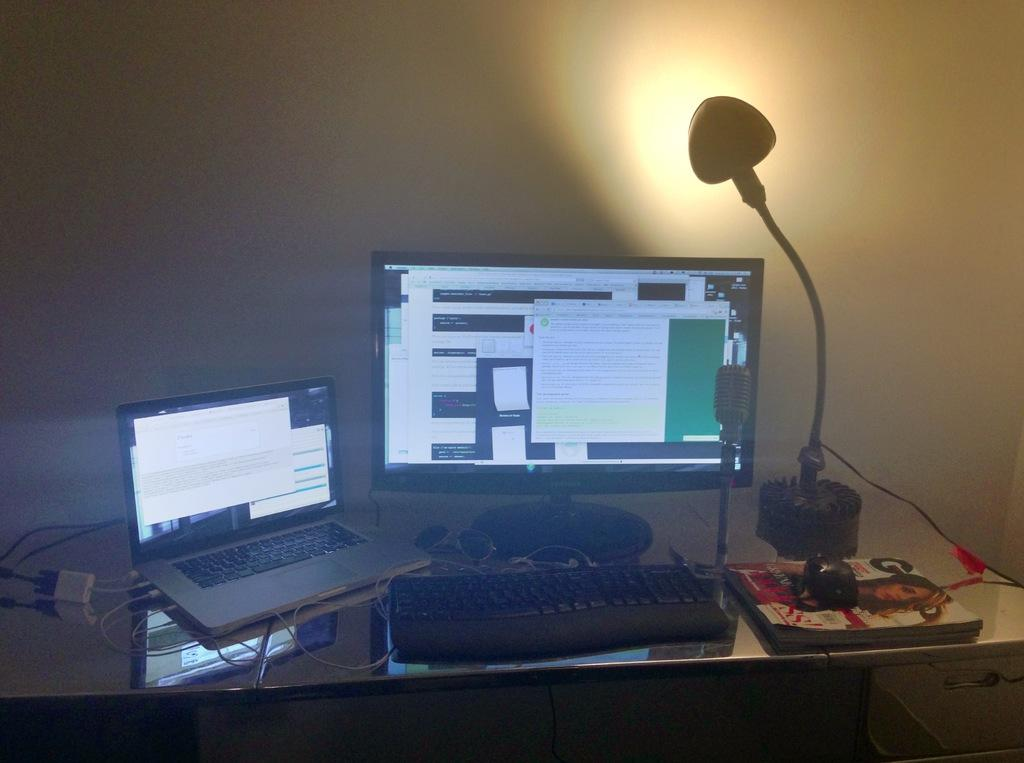Provide a one-sentence caption for the provided image. A GQ magazine sits next to a laptop and a desktop computer. 